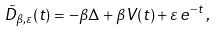Convert formula to latex. <formula><loc_0><loc_0><loc_500><loc_500>\tilde { D } _ { \beta , \varepsilon } ( t ) = - \beta \Delta + \beta V ( t ) + \varepsilon \, e ^ { - t } \, ,</formula> 